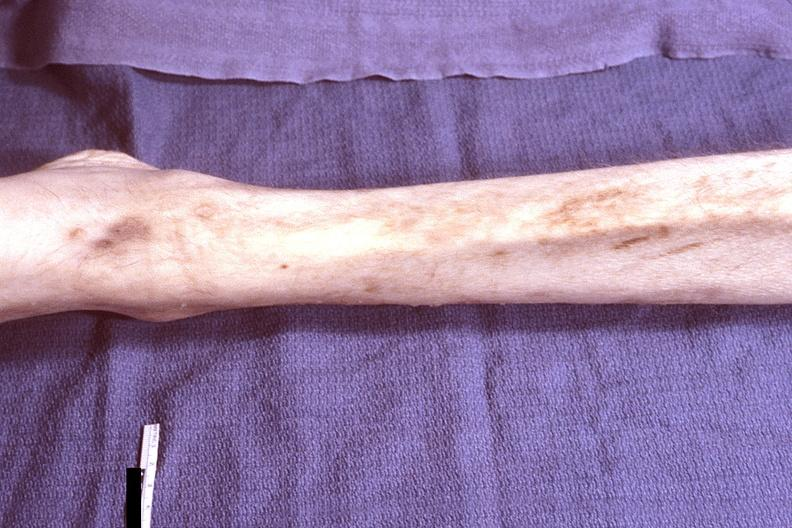what does this image show?
Answer the question using a single word or phrase. Leg - muscle wasting 